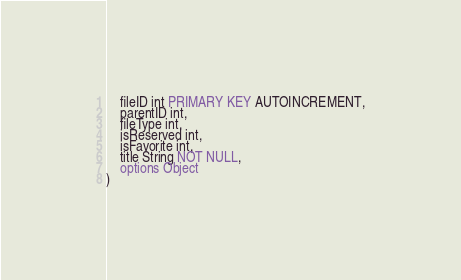Convert code to text. <code><loc_0><loc_0><loc_500><loc_500><_SQL_>	fileID int PRIMARY KEY AUTOINCREMENT,
	parentID int,
	fileType int,
	isReserved int,
	isFavorite int,
	title String NOT NULL,
	options Object
)</code> 